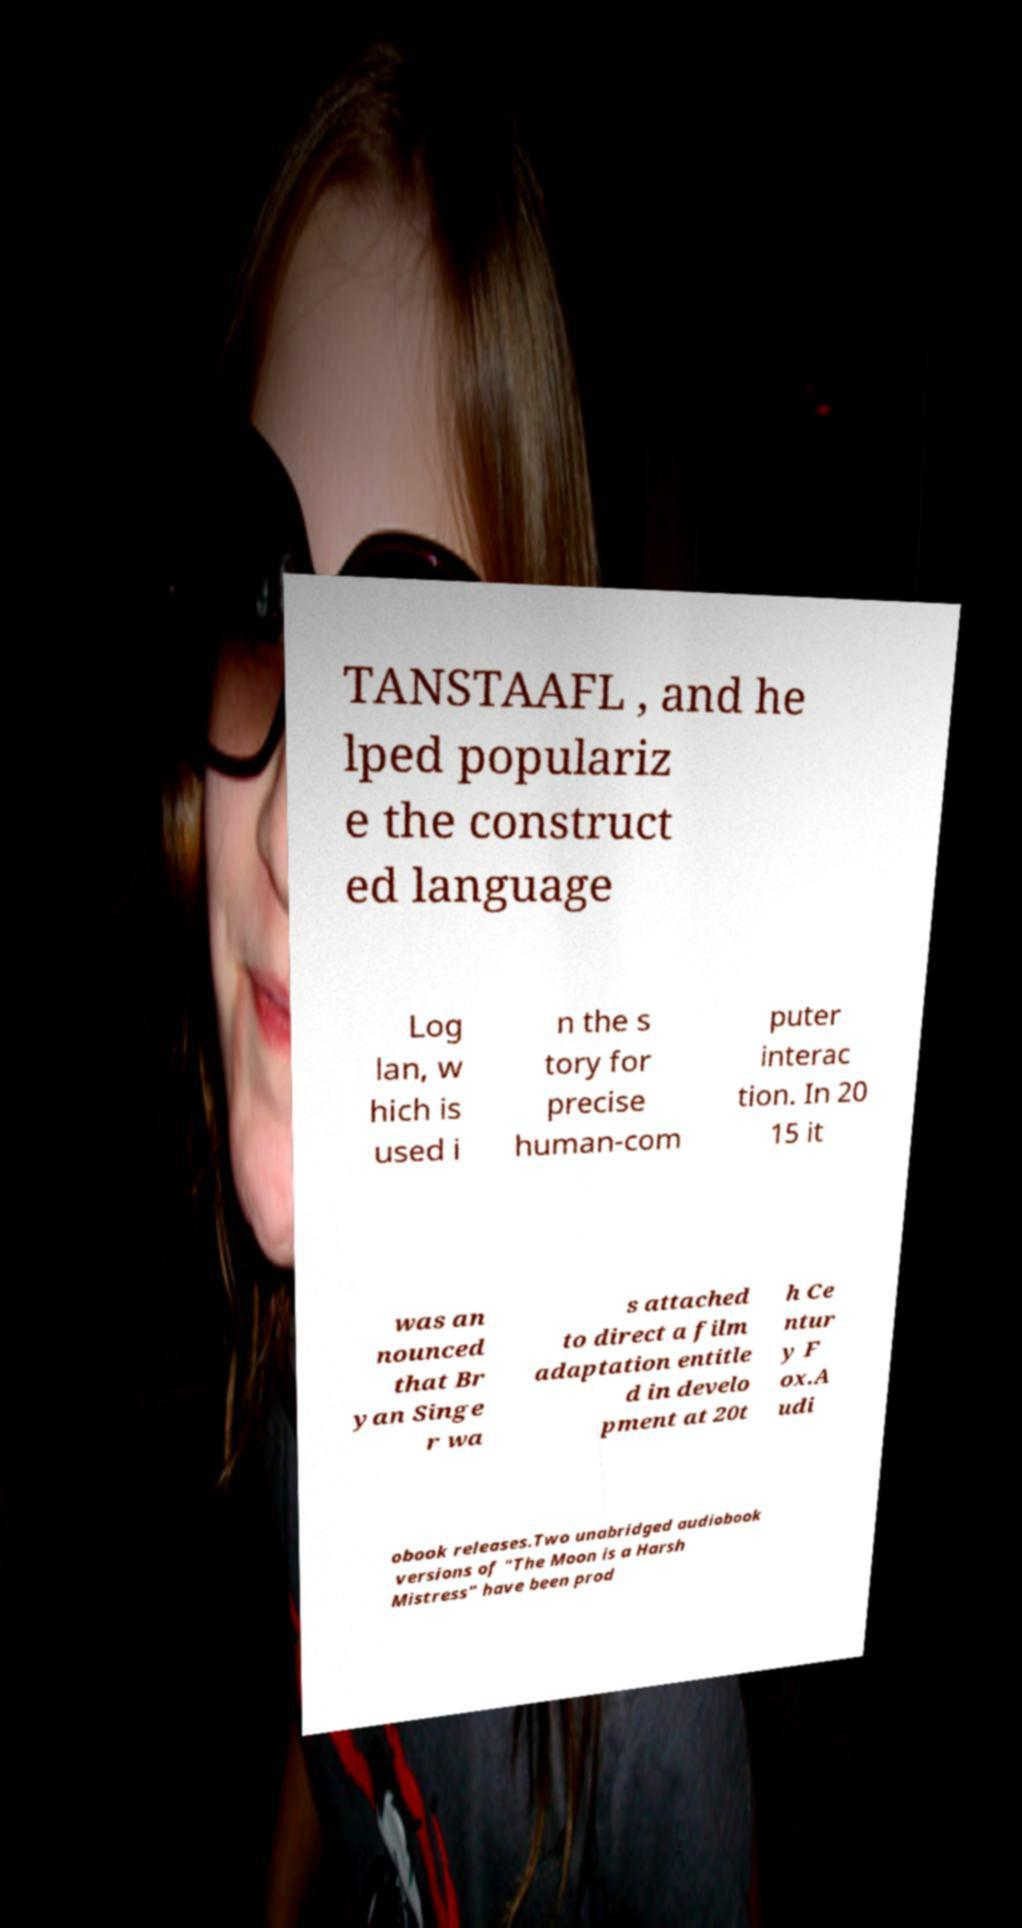I need the written content from this picture converted into text. Can you do that? TANSTAAFL , and he lped populariz e the construct ed language Log lan, w hich is used i n the s tory for precise human-com puter interac tion. In 20 15 it was an nounced that Br yan Singe r wa s attached to direct a film adaptation entitle d in develo pment at 20t h Ce ntur y F ox.A udi obook releases.Two unabridged audiobook versions of "The Moon is a Harsh Mistress" have been prod 